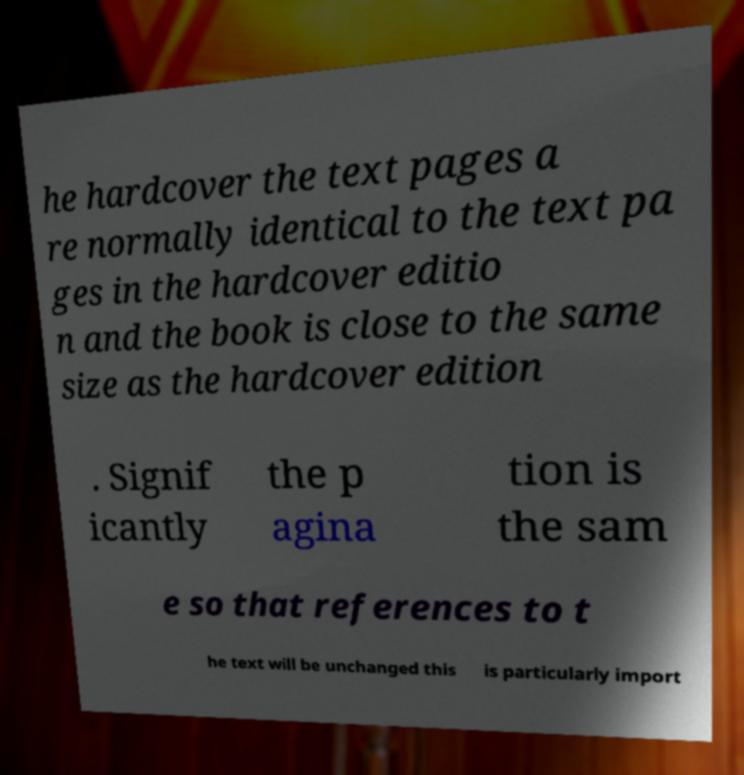For documentation purposes, I need the text within this image transcribed. Could you provide that? he hardcover the text pages a re normally identical to the text pa ges in the hardcover editio n and the book is close to the same size as the hardcover edition . Signif icantly the p agina tion is the sam e so that references to t he text will be unchanged this is particularly import 